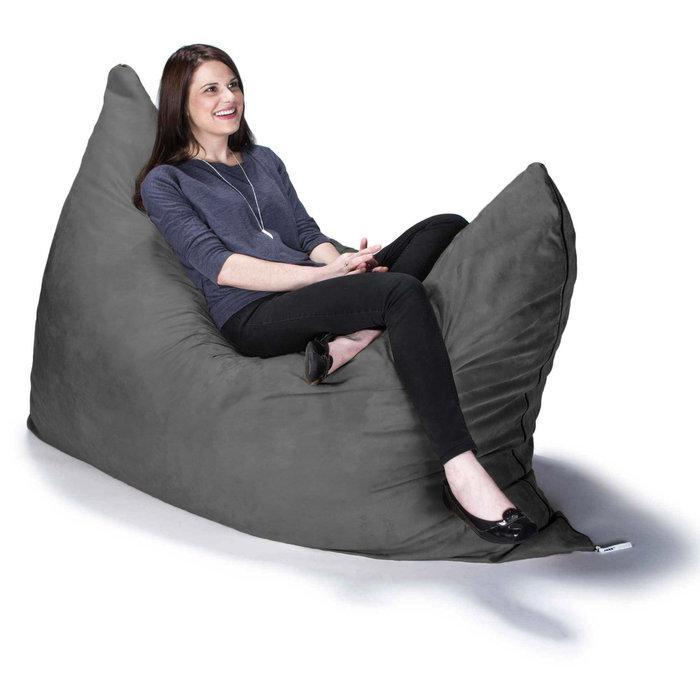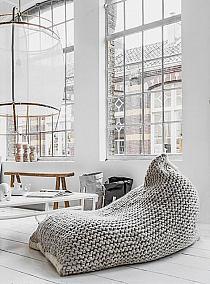The first image is the image on the left, the second image is the image on the right. Evaluate the accuracy of this statement regarding the images: "At least one of the cushions is knitted.". Is it true? Answer yes or no. Yes. 